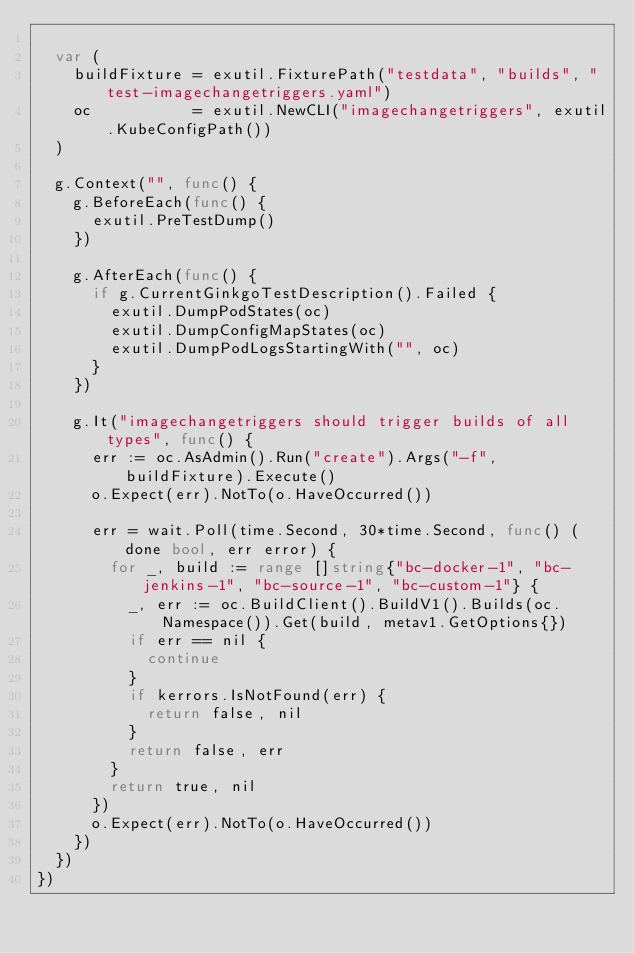<code> <loc_0><loc_0><loc_500><loc_500><_Go_>
	var (
		buildFixture = exutil.FixturePath("testdata", "builds", "test-imagechangetriggers.yaml")
		oc           = exutil.NewCLI("imagechangetriggers", exutil.KubeConfigPath())
	)

	g.Context("", func() {
		g.BeforeEach(func() {
			exutil.PreTestDump()
		})

		g.AfterEach(func() {
			if g.CurrentGinkgoTestDescription().Failed {
				exutil.DumpPodStates(oc)
				exutil.DumpConfigMapStates(oc)
				exutil.DumpPodLogsStartingWith("", oc)
			}
		})

		g.It("imagechangetriggers should trigger builds of all types", func() {
			err := oc.AsAdmin().Run("create").Args("-f", buildFixture).Execute()
			o.Expect(err).NotTo(o.HaveOccurred())

			err = wait.Poll(time.Second, 30*time.Second, func() (done bool, err error) {
				for _, build := range []string{"bc-docker-1", "bc-jenkins-1", "bc-source-1", "bc-custom-1"} {
					_, err := oc.BuildClient().BuildV1().Builds(oc.Namespace()).Get(build, metav1.GetOptions{})
					if err == nil {
						continue
					}
					if kerrors.IsNotFound(err) {
						return false, nil
					}
					return false, err
				}
				return true, nil
			})
			o.Expect(err).NotTo(o.HaveOccurred())
		})
	})
})
</code> 